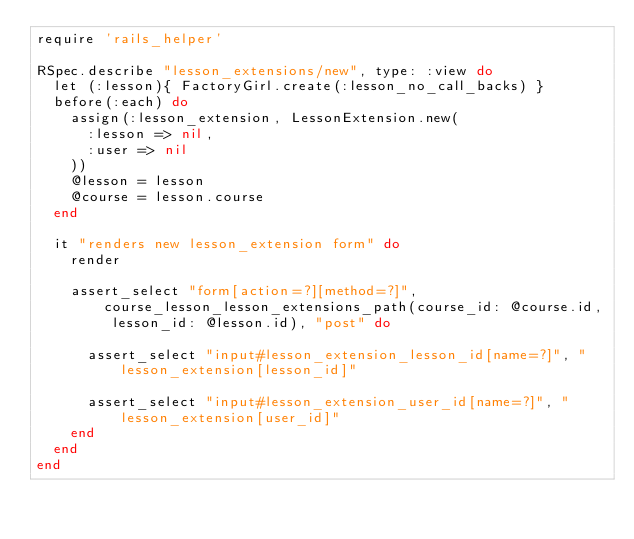<code> <loc_0><loc_0><loc_500><loc_500><_Ruby_>require 'rails_helper'

RSpec.describe "lesson_extensions/new", type: :view do
  let (:lesson){ FactoryGirl.create(:lesson_no_call_backs) }
  before(:each) do
    assign(:lesson_extension, LessonExtension.new(
      :lesson => nil,
      :user => nil
    ))
    @lesson = lesson
    @course = lesson.course
  end

  it "renders new lesson_extension form" do
    render

    assert_select "form[action=?][method=?]", course_lesson_lesson_extensions_path(course_id: @course.id, lesson_id: @lesson.id), "post" do

      assert_select "input#lesson_extension_lesson_id[name=?]", "lesson_extension[lesson_id]"

      assert_select "input#lesson_extension_user_id[name=?]", "lesson_extension[user_id]"
    end
  end
end
</code> 